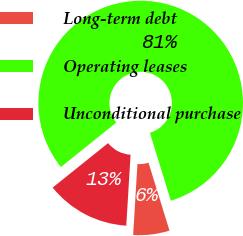<chart> <loc_0><loc_0><loc_500><loc_500><pie_chart><fcel>Long-term debt<fcel>Operating leases<fcel>Unconditional purchase<nl><fcel>5.73%<fcel>81.0%<fcel>13.28%<nl></chart> 